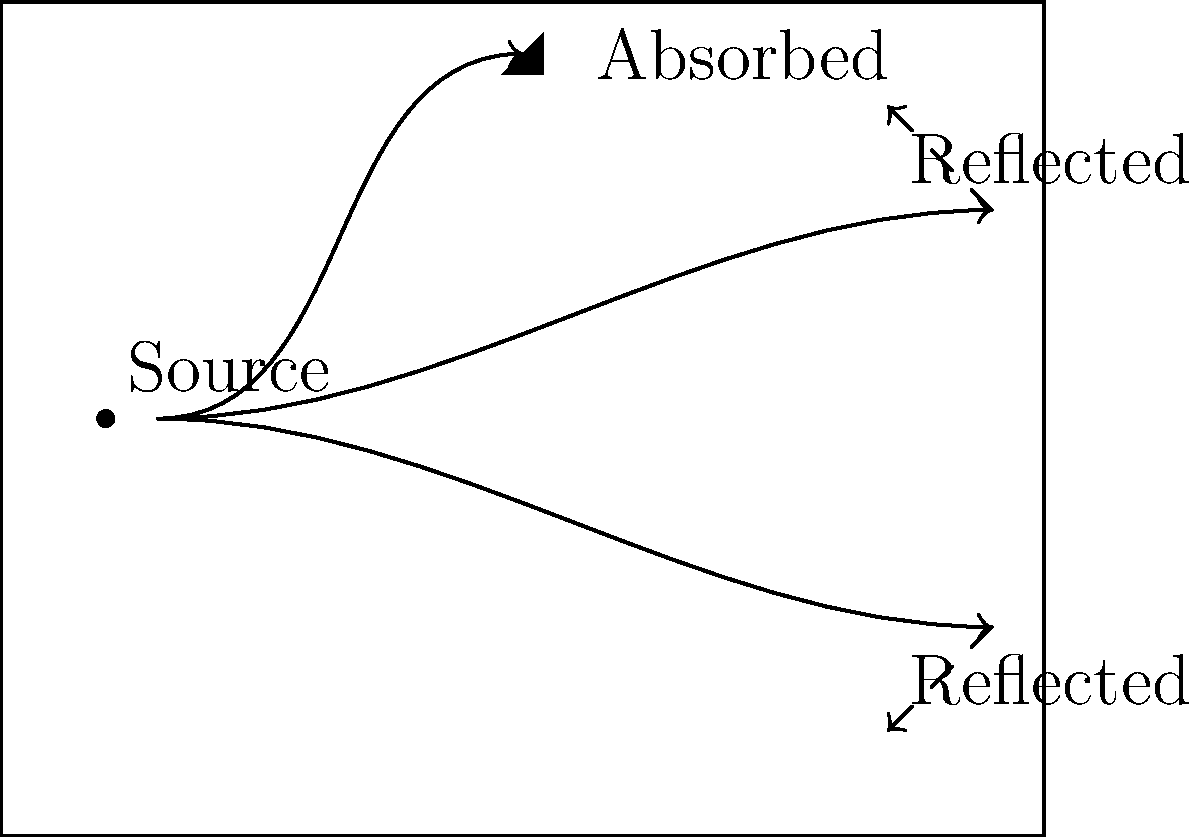At Kristiana Levy's concert, you notice the amazing acoustics in the hall. The diagram shows sound waves from the stage. What percentage of the sound waves shown are absorbed by the walls? To determine the percentage of sound waves absorbed, we need to:

1. Count the total number of sound waves shown:
   There are 3 sound waves depicted in the diagram.

2. Identify the number of absorbed waves:
   1 wave is shown being absorbed by the wall (top of the hall).

3. Calculate the percentage:
   Percentage = (Number of absorbed waves / Total number of waves) × 100
   Percentage = (1 / 3) × 100
   Percentage = 33.33%

Therefore, approximately 33.33% of the sound waves shown are absorbed by the walls.
Answer: 33.33% 